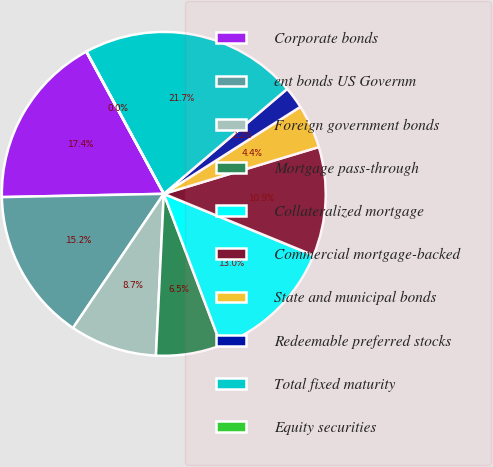<chart> <loc_0><loc_0><loc_500><loc_500><pie_chart><fcel>Corporate bonds<fcel>ent bonds US Governm<fcel>Foreign government bonds<fcel>Mortgage pass-through<fcel>Collateralized mortgage<fcel>Commercial mortgage-backed<fcel>State and municipal bonds<fcel>Redeemable preferred stocks<fcel>Total fixed maturity<fcel>Equity securities<nl><fcel>17.38%<fcel>15.21%<fcel>8.7%<fcel>6.53%<fcel>13.04%<fcel>10.87%<fcel>4.36%<fcel>2.19%<fcel>21.71%<fcel>0.02%<nl></chart> 